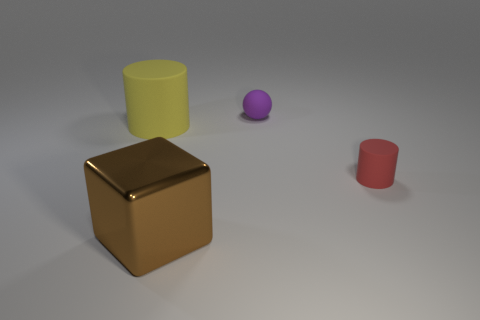Add 1 brown shiny cubes. How many objects exist? 5 Add 3 red metallic spheres. How many red metallic spheres exist? 3 Subtract 0 gray balls. How many objects are left? 4 Subtract all large purple metal things. Subtract all large yellow cylinders. How many objects are left? 3 Add 3 small matte spheres. How many small matte spheres are left? 4 